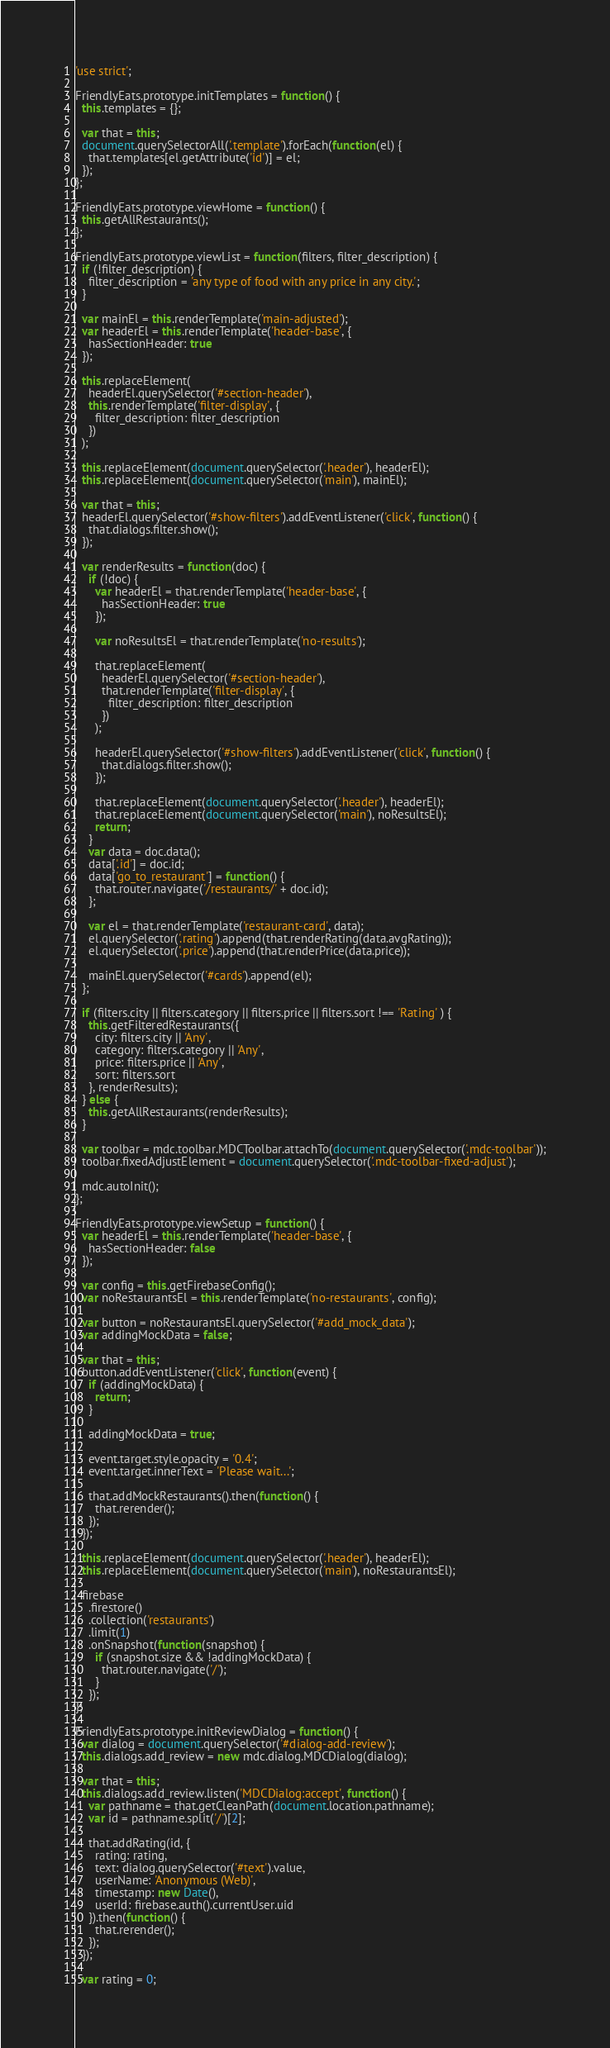Convert code to text. <code><loc_0><loc_0><loc_500><loc_500><_JavaScript_>
'use strict';

FriendlyEats.prototype.initTemplates = function() {
  this.templates = {};

  var that = this;
  document.querySelectorAll('.template').forEach(function(el) {
    that.templates[el.getAttribute('id')] = el;
  });
};

FriendlyEats.prototype.viewHome = function() {
  this.getAllRestaurants();
};

FriendlyEats.prototype.viewList = function(filters, filter_description) {
  if (!filter_description) {
    filter_description = 'any type of food with any price in any city.';
  }

  var mainEl = this.renderTemplate('main-adjusted');
  var headerEl = this.renderTemplate('header-base', {
    hasSectionHeader: true
  });

  this.replaceElement(
    headerEl.querySelector('#section-header'),
    this.renderTemplate('filter-display', {
      filter_description: filter_description
    })
  );

  this.replaceElement(document.querySelector('.header'), headerEl);
  this.replaceElement(document.querySelector('main'), mainEl);

  var that = this;
  headerEl.querySelector('#show-filters').addEventListener('click', function() {
    that.dialogs.filter.show();
  });

  var renderResults = function(doc) {
    if (!doc) {
      var headerEl = that.renderTemplate('header-base', {
        hasSectionHeader: true
      });

      var noResultsEl = that.renderTemplate('no-results');

      that.replaceElement(
        headerEl.querySelector('#section-header'),
        that.renderTemplate('filter-display', {
          filter_description: filter_description
        })
      );

      headerEl.querySelector('#show-filters').addEventListener('click', function() {
        that.dialogs.filter.show();
      });

      that.replaceElement(document.querySelector('.header'), headerEl);
      that.replaceElement(document.querySelector('main'), noResultsEl);
      return;
    }
    var data = doc.data();
    data['.id'] = doc.id;
    data['go_to_restaurant'] = function() {
      that.router.navigate('/restaurants/' + doc.id);
    };

    var el = that.renderTemplate('restaurant-card', data);
    el.querySelector('.rating').append(that.renderRating(data.avgRating));
    el.querySelector('.price').append(that.renderPrice(data.price));

    mainEl.querySelector('#cards').append(el);
  };

  if (filters.city || filters.category || filters.price || filters.sort !== 'Rating' ) {
    this.getFilteredRestaurants({
      city: filters.city || 'Any',
      category: filters.category || 'Any',
      price: filters.price || 'Any',
      sort: filters.sort
    }, renderResults);
  } else {
    this.getAllRestaurants(renderResults);
  }

  var toolbar = mdc.toolbar.MDCToolbar.attachTo(document.querySelector('.mdc-toolbar'));
  toolbar.fixedAdjustElement = document.querySelector('.mdc-toolbar-fixed-adjust');

  mdc.autoInit();
};

FriendlyEats.prototype.viewSetup = function() {
  var headerEl = this.renderTemplate('header-base', {
    hasSectionHeader: false
  });

  var config = this.getFirebaseConfig();
  var noRestaurantsEl = this.renderTemplate('no-restaurants', config);

  var button = noRestaurantsEl.querySelector('#add_mock_data');
  var addingMockData = false;

  var that = this;
  button.addEventListener('click', function(event) {
    if (addingMockData) {
      return;
    }

    addingMockData = true;

    event.target.style.opacity = '0.4';
    event.target.innerText = 'Please wait...';

    that.addMockRestaurants().then(function() {
      that.rerender();
    });
  });

  this.replaceElement(document.querySelector('.header'), headerEl);
  this.replaceElement(document.querySelector('main'), noRestaurantsEl);

  firebase
    .firestore()
    .collection('restaurants')
    .limit(1)
    .onSnapshot(function(snapshot) {
      if (snapshot.size && !addingMockData) {
        that.router.navigate('/');
      }
    });
};

FriendlyEats.prototype.initReviewDialog = function() {
  var dialog = document.querySelector('#dialog-add-review');
  this.dialogs.add_review = new mdc.dialog.MDCDialog(dialog);

  var that = this;
  this.dialogs.add_review.listen('MDCDialog:accept', function() {
    var pathname = that.getCleanPath(document.location.pathname);
    var id = pathname.split('/')[2];

    that.addRating(id, {
      rating: rating,
      text: dialog.querySelector('#text').value,
      userName: 'Anonymous (Web)',
      timestamp: new Date(),
      userId: firebase.auth().currentUser.uid
    }).then(function() {
      that.rerender();
    });
  });

  var rating = 0;
</code> 